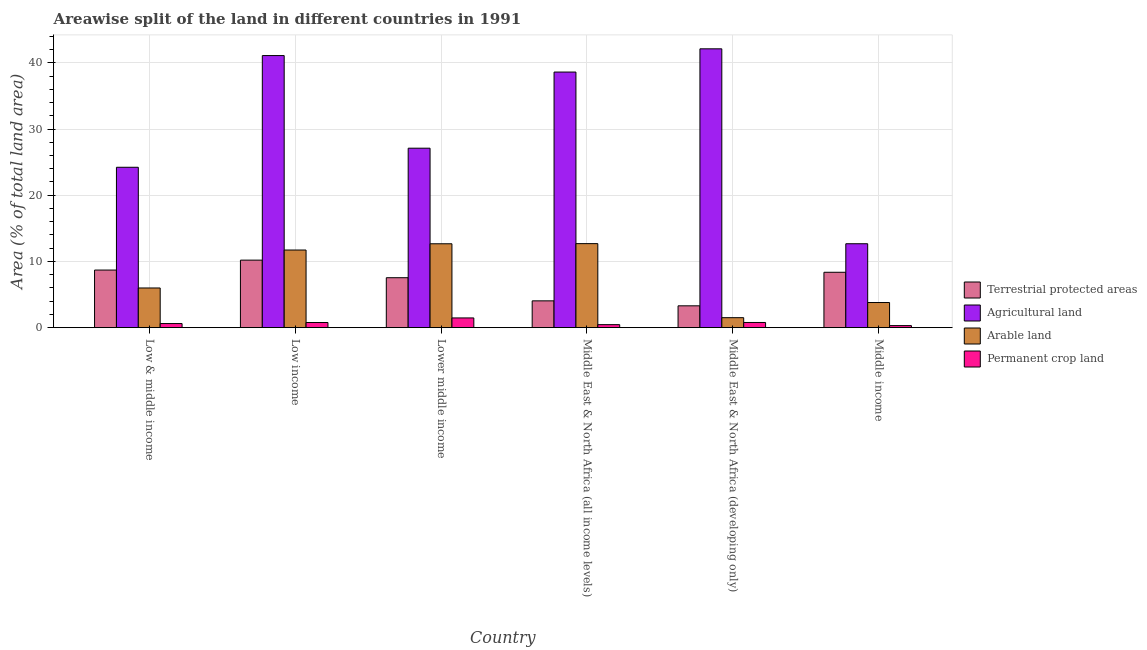How many different coloured bars are there?
Your response must be concise. 4. How many bars are there on the 3rd tick from the left?
Offer a very short reply. 4. What is the label of the 5th group of bars from the left?
Offer a very short reply. Middle East & North Africa (developing only). What is the percentage of land under terrestrial protection in Middle East & North Africa (all income levels)?
Your answer should be very brief. 4.05. Across all countries, what is the maximum percentage of area under permanent crop land?
Keep it short and to the point. 1.47. Across all countries, what is the minimum percentage of area under agricultural land?
Ensure brevity in your answer.  12.68. In which country was the percentage of area under permanent crop land maximum?
Give a very brief answer. Lower middle income. What is the total percentage of land under terrestrial protection in the graph?
Keep it short and to the point. 42.16. What is the difference between the percentage of area under arable land in Low & middle income and that in Lower middle income?
Ensure brevity in your answer.  -6.68. What is the difference between the percentage of land under terrestrial protection in Lower middle income and the percentage of area under permanent crop land in Middle East & North Africa (developing only)?
Give a very brief answer. 6.76. What is the average percentage of area under agricultural land per country?
Give a very brief answer. 30.97. What is the difference between the percentage of area under agricultural land and percentage of land under terrestrial protection in Low & middle income?
Offer a very short reply. 15.52. What is the ratio of the percentage of area under agricultural land in Low income to that in Middle income?
Provide a succinct answer. 3.24. Is the percentage of area under arable land in Low & middle income less than that in Middle income?
Keep it short and to the point. No. Is the difference between the percentage of area under agricultural land in Low & middle income and Middle East & North Africa (all income levels) greater than the difference between the percentage of area under permanent crop land in Low & middle income and Middle East & North Africa (all income levels)?
Offer a terse response. No. What is the difference between the highest and the second highest percentage of area under arable land?
Make the answer very short. 0.02. What is the difference between the highest and the lowest percentage of area under permanent crop land?
Your answer should be compact. 1.16. Is it the case that in every country, the sum of the percentage of area under agricultural land and percentage of land under terrestrial protection is greater than the sum of percentage of area under arable land and percentage of area under permanent crop land?
Make the answer very short. Yes. What does the 3rd bar from the left in Low income represents?
Your answer should be compact. Arable land. What does the 2nd bar from the right in Low & middle income represents?
Provide a succinct answer. Arable land. How many bars are there?
Offer a very short reply. 24. Are all the bars in the graph horizontal?
Keep it short and to the point. No. How many countries are there in the graph?
Your answer should be very brief. 6. What is the difference between two consecutive major ticks on the Y-axis?
Keep it short and to the point. 10. Are the values on the major ticks of Y-axis written in scientific E-notation?
Offer a very short reply. No. Does the graph contain any zero values?
Your response must be concise. No. How many legend labels are there?
Ensure brevity in your answer.  4. How are the legend labels stacked?
Your response must be concise. Vertical. What is the title of the graph?
Your response must be concise. Areawise split of the land in different countries in 1991. Does "Trade" appear as one of the legend labels in the graph?
Provide a short and direct response. No. What is the label or title of the Y-axis?
Offer a very short reply. Area (% of total land area). What is the Area (% of total land area) of Terrestrial protected areas in Low & middle income?
Offer a terse response. 8.7. What is the Area (% of total land area) of Agricultural land in Low & middle income?
Your answer should be compact. 24.22. What is the Area (% of total land area) of Arable land in Low & middle income?
Your answer should be compact. 5.99. What is the Area (% of total land area) of Permanent crop land in Low & middle income?
Offer a very short reply. 0.62. What is the Area (% of total land area) of Terrestrial protected areas in Low income?
Your response must be concise. 10.2. What is the Area (% of total land area) of Agricultural land in Low income?
Ensure brevity in your answer.  41.09. What is the Area (% of total land area) of Arable land in Low income?
Offer a terse response. 11.73. What is the Area (% of total land area) in Permanent crop land in Low income?
Ensure brevity in your answer.  0.78. What is the Area (% of total land area) in Terrestrial protected areas in Lower middle income?
Provide a succinct answer. 7.54. What is the Area (% of total land area) of Agricultural land in Lower middle income?
Make the answer very short. 27.1. What is the Area (% of total land area) in Arable land in Lower middle income?
Your answer should be very brief. 12.67. What is the Area (% of total land area) in Permanent crop land in Lower middle income?
Offer a very short reply. 1.47. What is the Area (% of total land area) of Terrestrial protected areas in Middle East & North Africa (all income levels)?
Keep it short and to the point. 4.05. What is the Area (% of total land area) of Agricultural land in Middle East & North Africa (all income levels)?
Ensure brevity in your answer.  38.6. What is the Area (% of total land area) of Arable land in Middle East & North Africa (all income levels)?
Ensure brevity in your answer.  12.69. What is the Area (% of total land area) of Permanent crop land in Middle East & North Africa (all income levels)?
Offer a terse response. 0.46. What is the Area (% of total land area) in Terrestrial protected areas in Middle East & North Africa (developing only)?
Give a very brief answer. 3.3. What is the Area (% of total land area) of Agricultural land in Middle East & North Africa (developing only)?
Offer a terse response. 42.11. What is the Area (% of total land area) in Arable land in Middle East & North Africa (developing only)?
Your response must be concise. 1.51. What is the Area (% of total land area) in Permanent crop land in Middle East & North Africa (developing only)?
Ensure brevity in your answer.  0.78. What is the Area (% of total land area) in Terrestrial protected areas in Middle income?
Make the answer very short. 8.36. What is the Area (% of total land area) in Agricultural land in Middle income?
Your answer should be compact. 12.68. What is the Area (% of total land area) in Arable land in Middle income?
Offer a very short reply. 3.8. What is the Area (% of total land area) of Permanent crop land in Middle income?
Ensure brevity in your answer.  0.31. Across all countries, what is the maximum Area (% of total land area) of Terrestrial protected areas?
Ensure brevity in your answer.  10.2. Across all countries, what is the maximum Area (% of total land area) in Agricultural land?
Your response must be concise. 42.11. Across all countries, what is the maximum Area (% of total land area) of Arable land?
Keep it short and to the point. 12.69. Across all countries, what is the maximum Area (% of total land area) of Permanent crop land?
Provide a short and direct response. 1.47. Across all countries, what is the minimum Area (% of total land area) in Terrestrial protected areas?
Give a very brief answer. 3.3. Across all countries, what is the minimum Area (% of total land area) of Agricultural land?
Make the answer very short. 12.68. Across all countries, what is the minimum Area (% of total land area) in Arable land?
Your answer should be compact. 1.51. Across all countries, what is the minimum Area (% of total land area) in Permanent crop land?
Provide a short and direct response. 0.31. What is the total Area (% of total land area) in Terrestrial protected areas in the graph?
Make the answer very short. 42.16. What is the total Area (% of total land area) of Agricultural land in the graph?
Ensure brevity in your answer.  185.81. What is the total Area (% of total land area) of Arable land in the graph?
Provide a succinct answer. 48.39. What is the total Area (% of total land area) of Permanent crop land in the graph?
Provide a short and direct response. 4.42. What is the difference between the Area (% of total land area) in Terrestrial protected areas in Low & middle income and that in Low income?
Offer a very short reply. -1.5. What is the difference between the Area (% of total land area) in Agricultural land in Low & middle income and that in Low income?
Offer a terse response. -16.87. What is the difference between the Area (% of total land area) of Arable land in Low & middle income and that in Low income?
Ensure brevity in your answer.  -5.73. What is the difference between the Area (% of total land area) of Permanent crop land in Low & middle income and that in Low income?
Provide a short and direct response. -0.16. What is the difference between the Area (% of total land area) in Terrestrial protected areas in Low & middle income and that in Lower middle income?
Make the answer very short. 1.16. What is the difference between the Area (% of total land area) in Agricultural land in Low & middle income and that in Lower middle income?
Offer a terse response. -2.88. What is the difference between the Area (% of total land area) of Arable land in Low & middle income and that in Lower middle income?
Ensure brevity in your answer.  -6.68. What is the difference between the Area (% of total land area) in Permanent crop land in Low & middle income and that in Lower middle income?
Offer a very short reply. -0.85. What is the difference between the Area (% of total land area) in Terrestrial protected areas in Low & middle income and that in Middle East & North Africa (all income levels)?
Give a very brief answer. 4.65. What is the difference between the Area (% of total land area) of Agricultural land in Low & middle income and that in Middle East & North Africa (all income levels)?
Ensure brevity in your answer.  -14.38. What is the difference between the Area (% of total land area) in Arable land in Low & middle income and that in Middle East & North Africa (all income levels)?
Ensure brevity in your answer.  -6.7. What is the difference between the Area (% of total land area) of Permanent crop land in Low & middle income and that in Middle East & North Africa (all income levels)?
Keep it short and to the point. 0.17. What is the difference between the Area (% of total land area) in Terrestrial protected areas in Low & middle income and that in Middle East & North Africa (developing only)?
Keep it short and to the point. 5.4. What is the difference between the Area (% of total land area) of Agricultural land in Low & middle income and that in Middle East & North Africa (developing only)?
Provide a short and direct response. -17.89. What is the difference between the Area (% of total land area) in Arable land in Low & middle income and that in Middle East & North Africa (developing only)?
Give a very brief answer. 4.49. What is the difference between the Area (% of total land area) of Permanent crop land in Low & middle income and that in Middle East & North Africa (developing only)?
Provide a short and direct response. -0.16. What is the difference between the Area (% of total land area) of Terrestrial protected areas in Low & middle income and that in Middle income?
Provide a short and direct response. 0.34. What is the difference between the Area (% of total land area) in Agricultural land in Low & middle income and that in Middle income?
Your answer should be very brief. 11.55. What is the difference between the Area (% of total land area) of Arable land in Low & middle income and that in Middle income?
Provide a short and direct response. 2.2. What is the difference between the Area (% of total land area) in Permanent crop land in Low & middle income and that in Middle income?
Provide a short and direct response. 0.31. What is the difference between the Area (% of total land area) in Terrestrial protected areas in Low income and that in Lower middle income?
Your response must be concise. 2.65. What is the difference between the Area (% of total land area) of Agricultural land in Low income and that in Lower middle income?
Ensure brevity in your answer.  13.99. What is the difference between the Area (% of total land area) of Arable land in Low income and that in Lower middle income?
Provide a succinct answer. -0.94. What is the difference between the Area (% of total land area) of Permanent crop land in Low income and that in Lower middle income?
Your answer should be compact. -0.69. What is the difference between the Area (% of total land area) of Terrestrial protected areas in Low income and that in Middle East & North Africa (all income levels)?
Ensure brevity in your answer.  6.15. What is the difference between the Area (% of total land area) in Agricultural land in Low income and that in Middle East & North Africa (all income levels)?
Your response must be concise. 2.49. What is the difference between the Area (% of total land area) in Arable land in Low income and that in Middle East & North Africa (all income levels)?
Offer a very short reply. -0.96. What is the difference between the Area (% of total land area) in Permanent crop land in Low income and that in Middle East & North Africa (all income levels)?
Offer a terse response. 0.32. What is the difference between the Area (% of total land area) in Terrestrial protected areas in Low income and that in Middle East & North Africa (developing only)?
Provide a short and direct response. 6.9. What is the difference between the Area (% of total land area) in Agricultural land in Low income and that in Middle East & North Africa (developing only)?
Your response must be concise. -1.02. What is the difference between the Area (% of total land area) of Arable land in Low income and that in Middle East & North Africa (developing only)?
Offer a very short reply. 10.22. What is the difference between the Area (% of total land area) in Permanent crop land in Low income and that in Middle East & North Africa (developing only)?
Your response must be concise. -0.01. What is the difference between the Area (% of total land area) of Terrestrial protected areas in Low income and that in Middle income?
Ensure brevity in your answer.  1.83. What is the difference between the Area (% of total land area) of Agricultural land in Low income and that in Middle income?
Your answer should be very brief. 28.42. What is the difference between the Area (% of total land area) of Arable land in Low income and that in Middle income?
Your answer should be very brief. 7.93. What is the difference between the Area (% of total land area) in Permanent crop land in Low income and that in Middle income?
Provide a short and direct response. 0.47. What is the difference between the Area (% of total land area) of Terrestrial protected areas in Lower middle income and that in Middle East & North Africa (all income levels)?
Your answer should be very brief. 3.49. What is the difference between the Area (% of total land area) of Agricultural land in Lower middle income and that in Middle East & North Africa (all income levels)?
Provide a short and direct response. -11.5. What is the difference between the Area (% of total land area) in Arable land in Lower middle income and that in Middle East & North Africa (all income levels)?
Your response must be concise. -0.02. What is the difference between the Area (% of total land area) of Permanent crop land in Lower middle income and that in Middle East & North Africa (all income levels)?
Offer a very short reply. 1.01. What is the difference between the Area (% of total land area) of Terrestrial protected areas in Lower middle income and that in Middle East & North Africa (developing only)?
Provide a short and direct response. 4.25. What is the difference between the Area (% of total land area) of Agricultural land in Lower middle income and that in Middle East & North Africa (developing only)?
Keep it short and to the point. -15.01. What is the difference between the Area (% of total land area) of Arable land in Lower middle income and that in Middle East & North Africa (developing only)?
Your answer should be very brief. 11.16. What is the difference between the Area (% of total land area) of Permanent crop land in Lower middle income and that in Middle East & North Africa (developing only)?
Ensure brevity in your answer.  0.69. What is the difference between the Area (% of total land area) in Terrestrial protected areas in Lower middle income and that in Middle income?
Provide a short and direct response. -0.82. What is the difference between the Area (% of total land area) of Agricultural land in Lower middle income and that in Middle income?
Make the answer very short. 14.43. What is the difference between the Area (% of total land area) in Arable land in Lower middle income and that in Middle income?
Make the answer very short. 8.87. What is the difference between the Area (% of total land area) of Permanent crop land in Lower middle income and that in Middle income?
Give a very brief answer. 1.16. What is the difference between the Area (% of total land area) of Terrestrial protected areas in Middle East & North Africa (all income levels) and that in Middle East & North Africa (developing only)?
Provide a short and direct response. 0.75. What is the difference between the Area (% of total land area) in Agricultural land in Middle East & North Africa (all income levels) and that in Middle East & North Africa (developing only)?
Your response must be concise. -3.51. What is the difference between the Area (% of total land area) in Arable land in Middle East & North Africa (all income levels) and that in Middle East & North Africa (developing only)?
Offer a very short reply. 11.18. What is the difference between the Area (% of total land area) in Permanent crop land in Middle East & North Africa (all income levels) and that in Middle East & North Africa (developing only)?
Your answer should be very brief. -0.33. What is the difference between the Area (% of total land area) in Terrestrial protected areas in Middle East & North Africa (all income levels) and that in Middle income?
Make the answer very short. -4.31. What is the difference between the Area (% of total land area) in Agricultural land in Middle East & North Africa (all income levels) and that in Middle income?
Your response must be concise. 25.93. What is the difference between the Area (% of total land area) in Arable land in Middle East & North Africa (all income levels) and that in Middle income?
Offer a very short reply. 8.9. What is the difference between the Area (% of total land area) in Permanent crop land in Middle East & North Africa (all income levels) and that in Middle income?
Your answer should be very brief. 0.14. What is the difference between the Area (% of total land area) in Terrestrial protected areas in Middle East & North Africa (developing only) and that in Middle income?
Offer a very short reply. -5.07. What is the difference between the Area (% of total land area) in Agricultural land in Middle East & North Africa (developing only) and that in Middle income?
Keep it short and to the point. 29.44. What is the difference between the Area (% of total land area) in Arable land in Middle East & North Africa (developing only) and that in Middle income?
Provide a short and direct response. -2.29. What is the difference between the Area (% of total land area) in Permanent crop land in Middle East & North Africa (developing only) and that in Middle income?
Offer a terse response. 0.47. What is the difference between the Area (% of total land area) in Terrestrial protected areas in Low & middle income and the Area (% of total land area) in Agricultural land in Low income?
Your answer should be compact. -32.39. What is the difference between the Area (% of total land area) in Terrestrial protected areas in Low & middle income and the Area (% of total land area) in Arable land in Low income?
Offer a very short reply. -3.03. What is the difference between the Area (% of total land area) of Terrestrial protected areas in Low & middle income and the Area (% of total land area) of Permanent crop land in Low income?
Your answer should be very brief. 7.92. What is the difference between the Area (% of total land area) of Agricultural land in Low & middle income and the Area (% of total land area) of Arable land in Low income?
Make the answer very short. 12.5. What is the difference between the Area (% of total land area) in Agricultural land in Low & middle income and the Area (% of total land area) in Permanent crop land in Low income?
Your response must be concise. 23.45. What is the difference between the Area (% of total land area) of Arable land in Low & middle income and the Area (% of total land area) of Permanent crop land in Low income?
Your answer should be compact. 5.22. What is the difference between the Area (% of total land area) of Terrestrial protected areas in Low & middle income and the Area (% of total land area) of Agricultural land in Lower middle income?
Provide a succinct answer. -18.4. What is the difference between the Area (% of total land area) of Terrestrial protected areas in Low & middle income and the Area (% of total land area) of Arable land in Lower middle income?
Offer a very short reply. -3.97. What is the difference between the Area (% of total land area) in Terrestrial protected areas in Low & middle income and the Area (% of total land area) in Permanent crop land in Lower middle income?
Give a very brief answer. 7.23. What is the difference between the Area (% of total land area) in Agricultural land in Low & middle income and the Area (% of total land area) in Arable land in Lower middle income?
Your answer should be compact. 11.55. What is the difference between the Area (% of total land area) of Agricultural land in Low & middle income and the Area (% of total land area) of Permanent crop land in Lower middle income?
Provide a succinct answer. 22.75. What is the difference between the Area (% of total land area) in Arable land in Low & middle income and the Area (% of total land area) in Permanent crop land in Lower middle income?
Provide a short and direct response. 4.52. What is the difference between the Area (% of total land area) in Terrestrial protected areas in Low & middle income and the Area (% of total land area) in Agricultural land in Middle East & North Africa (all income levels)?
Offer a very short reply. -29.9. What is the difference between the Area (% of total land area) in Terrestrial protected areas in Low & middle income and the Area (% of total land area) in Arable land in Middle East & North Africa (all income levels)?
Offer a terse response. -3.99. What is the difference between the Area (% of total land area) in Terrestrial protected areas in Low & middle income and the Area (% of total land area) in Permanent crop land in Middle East & North Africa (all income levels)?
Make the answer very short. 8.24. What is the difference between the Area (% of total land area) of Agricultural land in Low & middle income and the Area (% of total land area) of Arable land in Middle East & North Africa (all income levels)?
Your answer should be compact. 11.53. What is the difference between the Area (% of total land area) in Agricultural land in Low & middle income and the Area (% of total land area) in Permanent crop land in Middle East & North Africa (all income levels)?
Your answer should be very brief. 23.77. What is the difference between the Area (% of total land area) in Arable land in Low & middle income and the Area (% of total land area) in Permanent crop land in Middle East & North Africa (all income levels)?
Your answer should be very brief. 5.54. What is the difference between the Area (% of total land area) in Terrestrial protected areas in Low & middle income and the Area (% of total land area) in Agricultural land in Middle East & North Africa (developing only)?
Give a very brief answer. -33.41. What is the difference between the Area (% of total land area) in Terrestrial protected areas in Low & middle income and the Area (% of total land area) in Arable land in Middle East & North Africa (developing only)?
Make the answer very short. 7.19. What is the difference between the Area (% of total land area) in Terrestrial protected areas in Low & middle income and the Area (% of total land area) in Permanent crop land in Middle East & North Africa (developing only)?
Give a very brief answer. 7.92. What is the difference between the Area (% of total land area) in Agricultural land in Low & middle income and the Area (% of total land area) in Arable land in Middle East & North Africa (developing only)?
Offer a terse response. 22.72. What is the difference between the Area (% of total land area) in Agricultural land in Low & middle income and the Area (% of total land area) in Permanent crop land in Middle East & North Africa (developing only)?
Your answer should be very brief. 23.44. What is the difference between the Area (% of total land area) of Arable land in Low & middle income and the Area (% of total land area) of Permanent crop land in Middle East & North Africa (developing only)?
Offer a terse response. 5.21. What is the difference between the Area (% of total land area) of Terrestrial protected areas in Low & middle income and the Area (% of total land area) of Agricultural land in Middle income?
Offer a terse response. -3.98. What is the difference between the Area (% of total land area) in Terrestrial protected areas in Low & middle income and the Area (% of total land area) in Arable land in Middle income?
Offer a terse response. 4.9. What is the difference between the Area (% of total land area) in Terrestrial protected areas in Low & middle income and the Area (% of total land area) in Permanent crop land in Middle income?
Your response must be concise. 8.39. What is the difference between the Area (% of total land area) in Agricultural land in Low & middle income and the Area (% of total land area) in Arable land in Middle income?
Offer a very short reply. 20.43. What is the difference between the Area (% of total land area) in Agricultural land in Low & middle income and the Area (% of total land area) in Permanent crop land in Middle income?
Provide a short and direct response. 23.91. What is the difference between the Area (% of total land area) in Arable land in Low & middle income and the Area (% of total land area) in Permanent crop land in Middle income?
Offer a terse response. 5.68. What is the difference between the Area (% of total land area) of Terrestrial protected areas in Low income and the Area (% of total land area) of Agricultural land in Lower middle income?
Give a very brief answer. -16.9. What is the difference between the Area (% of total land area) of Terrestrial protected areas in Low income and the Area (% of total land area) of Arable land in Lower middle income?
Keep it short and to the point. -2.47. What is the difference between the Area (% of total land area) in Terrestrial protected areas in Low income and the Area (% of total land area) in Permanent crop land in Lower middle income?
Keep it short and to the point. 8.73. What is the difference between the Area (% of total land area) of Agricultural land in Low income and the Area (% of total land area) of Arable land in Lower middle income?
Provide a short and direct response. 28.42. What is the difference between the Area (% of total land area) in Agricultural land in Low income and the Area (% of total land area) in Permanent crop land in Lower middle income?
Ensure brevity in your answer.  39.62. What is the difference between the Area (% of total land area) of Arable land in Low income and the Area (% of total land area) of Permanent crop land in Lower middle income?
Your response must be concise. 10.26. What is the difference between the Area (% of total land area) in Terrestrial protected areas in Low income and the Area (% of total land area) in Agricultural land in Middle East & North Africa (all income levels)?
Ensure brevity in your answer.  -28.4. What is the difference between the Area (% of total land area) of Terrestrial protected areas in Low income and the Area (% of total land area) of Arable land in Middle East & North Africa (all income levels)?
Your answer should be compact. -2.49. What is the difference between the Area (% of total land area) of Terrestrial protected areas in Low income and the Area (% of total land area) of Permanent crop land in Middle East & North Africa (all income levels)?
Make the answer very short. 9.74. What is the difference between the Area (% of total land area) of Agricultural land in Low income and the Area (% of total land area) of Arable land in Middle East & North Africa (all income levels)?
Your response must be concise. 28.4. What is the difference between the Area (% of total land area) in Agricultural land in Low income and the Area (% of total land area) in Permanent crop land in Middle East & North Africa (all income levels)?
Ensure brevity in your answer.  40.64. What is the difference between the Area (% of total land area) in Arable land in Low income and the Area (% of total land area) in Permanent crop land in Middle East & North Africa (all income levels)?
Keep it short and to the point. 11.27. What is the difference between the Area (% of total land area) in Terrestrial protected areas in Low income and the Area (% of total land area) in Agricultural land in Middle East & North Africa (developing only)?
Give a very brief answer. -31.91. What is the difference between the Area (% of total land area) in Terrestrial protected areas in Low income and the Area (% of total land area) in Arable land in Middle East & North Africa (developing only)?
Provide a short and direct response. 8.69. What is the difference between the Area (% of total land area) of Terrestrial protected areas in Low income and the Area (% of total land area) of Permanent crop land in Middle East & North Africa (developing only)?
Make the answer very short. 9.41. What is the difference between the Area (% of total land area) of Agricultural land in Low income and the Area (% of total land area) of Arable land in Middle East & North Africa (developing only)?
Offer a terse response. 39.59. What is the difference between the Area (% of total land area) of Agricultural land in Low income and the Area (% of total land area) of Permanent crop land in Middle East & North Africa (developing only)?
Ensure brevity in your answer.  40.31. What is the difference between the Area (% of total land area) of Arable land in Low income and the Area (% of total land area) of Permanent crop land in Middle East & North Africa (developing only)?
Your response must be concise. 10.94. What is the difference between the Area (% of total land area) in Terrestrial protected areas in Low income and the Area (% of total land area) in Agricultural land in Middle income?
Provide a succinct answer. -2.48. What is the difference between the Area (% of total land area) in Terrestrial protected areas in Low income and the Area (% of total land area) in Arable land in Middle income?
Your response must be concise. 6.4. What is the difference between the Area (% of total land area) in Terrestrial protected areas in Low income and the Area (% of total land area) in Permanent crop land in Middle income?
Give a very brief answer. 9.89. What is the difference between the Area (% of total land area) of Agricultural land in Low income and the Area (% of total land area) of Arable land in Middle income?
Make the answer very short. 37.3. What is the difference between the Area (% of total land area) of Agricultural land in Low income and the Area (% of total land area) of Permanent crop land in Middle income?
Ensure brevity in your answer.  40.78. What is the difference between the Area (% of total land area) in Arable land in Low income and the Area (% of total land area) in Permanent crop land in Middle income?
Make the answer very short. 11.42. What is the difference between the Area (% of total land area) of Terrestrial protected areas in Lower middle income and the Area (% of total land area) of Agricultural land in Middle East & North Africa (all income levels)?
Provide a short and direct response. -31.06. What is the difference between the Area (% of total land area) in Terrestrial protected areas in Lower middle income and the Area (% of total land area) in Arable land in Middle East & North Africa (all income levels)?
Offer a terse response. -5.15. What is the difference between the Area (% of total land area) of Terrestrial protected areas in Lower middle income and the Area (% of total land area) of Permanent crop land in Middle East & North Africa (all income levels)?
Provide a short and direct response. 7.09. What is the difference between the Area (% of total land area) of Agricultural land in Lower middle income and the Area (% of total land area) of Arable land in Middle East & North Africa (all income levels)?
Keep it short and to the point. 14.41. What is the difference between the Area (% of total land area) in Agricultural land in Lower middle income and the Area (% of total land area) in Permanent crop land in Middle East & North Africa (all income levels)?
Offer a very short reply. 26.65. What is the difference between the Area (% of total land area) in Arable land in Lower middle income and the Area (% of total land area) in Permanent crop land in Middle East & North Africa (all income levels)?
Ensure brevity in your answer.  12.21. What is the difference between the Area (% of total land area) in Terrestrial protected areas in Lower middle income and the Area (% of total land area) in Agricultural land in Middle East & North Africa (developing only)?
Keep it short and to the point. -34.57. What is the difference between the Area (% of total land area) in Terrestrial protected areas in Lower middle income and the Area (% of total land area) in Arable land in Middle East & North Africa (developing only)?
Offer a terse response. 6.04. What is the difference between the Area (% of total land area) of Terrestrial protected areas in Lower middle income and the Area (% of total land area) of Permanent crop land in Middle East & North Africa (developing only)?
Ensure brevity in your answer.  6.76. What is the difference between the Area (% of total land area) of Agricultural land in Lower middle income and the Area (% of total land area) of Arable land in Middle East & North Africa (developing only)?
Keep it short and to the point. 25.6. What is the difference between the Area (% of total land area) of Agricultural land in Lower middle income and the Area (% of total land area) of Permanent crop land in Middle East & North Africa (developing only)?
Ensure brevity in your answer.  26.32. What is the difference between the Area (% of total land area) in Arable land in Lower middle income and the Area (% of total land area) in Permanent crop land in Middle East & North Africa (developing only)?
Your answer should be very brief. 11.88. What is the difference between the Area (% of total land area) in Terrestrial protected areas in Lower middle income and the Area (% of total land area) in Agricultural land in Middle income?
Your answer should be compact. -5.13. What is the difference between the Area (% of total land area) of Terrestrial protected areas in Lower middle income and the Area (% of total land area) of Arable land in Middle income?
Make the answer very short. 3.75. What is the difference between the Area (% of total land area) in Terrestrial protected areas in Lower middle income and the Area (% of total land area) in Permanent crop land in Middle income?
Keep it short and to the point. 7.23. What is the difference between the Area (% of total land area) in Agricultural land in Lower middle income and the Area (% of total land area) in Arable land in Middle income?
Make the answer very short. 23.31. What is the difference between the Area (% of total land area) in Agricultural land in Lower middle income and the Area (% of total land area) in Permanent crop land in Middle income?
Your answer should be very brief. 26.79. What is the difference between the Area (% of total land area) in Arable land in Lower middle income and the Area (% of total land area) in Permanent crop land in Middle income?
Your response must be concise. 12.36. What is the difference between the Area (% of total land area) in Terrestrial protected areas in Middle East & North Africa (all income levels) and the Area (% of total land area) in Agricultural land in Middle East & North Africa (developing only)?
Make the answer very short. -38.06. What is the difference between the Area (% of total land area) of Terrestrial protected areas in Middle East & North Africa (all income levels) and the Area (% of total land area) of Arable land in Middle East & North Africa (developing only)?
Your answer should be compact. 2.54. What is the difference between the Area (% of total land area) of Terrestrial protected areas in Middle East & North Africa (all income levels) and the Area (% of total land area) of Permanent crop land in Middle East & North Africa (developing only)?
Provide a short and direct response. 3.27. What is the difference between the Area (% of total land area) of Agricultural land in Middle East & North Africa (all income levels) and the Area (% of total land area) of Arable land in Middle East & North Africa (developing only)?
Your response must be concise. 37.1. What is the difference between the Area (% of total land area) of Agricultural land in Middle East & North Africa (all income levels) and the Area (% of total land area) of Permanent crop land in Middle East & North Africa (developing only)?
Give a very brief answer. 37.82. What is the difference between the Area (% of total land area) of Arable land in Middle East & North Africa (all income levels) and the Area (% of total land area) of Permanent crop land in Middle East & North Africa (developing only)?
Give a very brief answer. 11.91. What is the difference between the Area (% of total land area) in Terrestrial protected areas in Middle East & North Africa (all income levels) and the Area (% of total land area) in Agricultural land in Middle income?
Your answer should be very brief. -8.63. What is the difference between the Area (% of total land area) of Terrestrial protected areas in Middle East & North Africa (all income levels) and the Area (% of total land area) of Arable land in Middle income?
Give a very brief answer. 0.25. What is the difference between the Area (% of total land area) in Terrestrial protected areas in Middle East & North Africa (all income levels) and the Area (% of total land area) in Permanent crop land in Middle income?
Make the answer very short. 3.74. What is the difference between the Area (% of total land area) of Agricultural land in Middle East & North Africa (all income levels) and the Area (% of total land area) of Arable land in Middle income?
Keep it short and to the point. 34.81. What is the difference between the Area (% of total land area) in Agricultural land in Middle East & North Africa (all income levels) and the Area (% of total land area) in Permanent crop land in Middle income?
Your response must be concise. 38.29. What is the difference between the Area (% of total land area) in Arable land in Middle East & North Africa (all income levels) and the Area (% of total land area) in Permanent crop land in Middle income?
Ensure brevity in your answer.  12.38. What is the difference between the Area (% of total land area) in Terrestrial protected areas in Middle East & North Africa (developing only) and the Area (% of total land area) in Agricultural land in Middle income?
Your response must be concise. -9.38. What is the difference between the Area (% of total land area) of Terrestrial protected areas in Middle East & North Africa (developing only) and the Area (% of total land area) of Arable land in Middle income?
Your answer should be very brief. -0.5. What is the difference between the Area (% of total land area) in Terrestrial protected areas in Middle East & North Africa (developing only) and the Area (% of total land area) in Permanent crop land in Middle income?
Provide a succinct answer. 2.99. What is the difference between the Area (% of total land area) of Agricultural land in Middle East & North Africa (developing only) and the Area (% of total land area) of Arable land in Middle income?
Give a very brief answer. 38.32. What is the difference between the Area (% of total land area) in Agricultural land in Middle East & North Africa (developing only) and the Area (% of total land area) in Permanent crop land in Middle income?
Ensure brevity in your answer.  41.8. What is the difference between the Area (% of total land area) of Arable land in Middle East & North Africa (developing only) and the Area (% of total land area) of Permanent crop land in Middle income?
Ensure brevity in your answer.  1.2. What is the average Area (% of total land area) in Terrestrial protected areas per country?
Make the answer very short. 7.03. What is the average Area (% of total land area) of Agricultural land per country?
Your response must be concise. 30.97. What is the average Area (% of total land area) of Arable land per country?
Your answer should be compact. 8.06. What is the average Area (% of total land area) in Permanent crop land per country?
Provide a succinct answer. 0.74. What is the difference between the Area (% of total land area) of Terrestrial protected areas and Area (% of total land area) of Agricultural land in Low & middle income?
Offer a terse response. -15.52. What is the difference between the Area (% of total land area) of Terrestrial protected areas and Area (% of total land area) of Arable land in Low & middle income?
Keep it short and to the point. 2.71. What is the difference between the Area (% of total land area) in Terrestrial protected areas and Area (% of total land area) in Permanent crop land in Low & middle income?
Your response must be concise. 8.08. What is the difference between the Area (% of total land area) in Agricultural land and Area (% of total land area) in Arable land in Low & middle income?
Provide a succinct answer. 18.23. What is the difference between the Area (% of total land area) in Agricultural land and Area (% of total land area) in Permanent crop land in Low & middle income?
Provide a short and direct response. 23.6. What is the difference between the Area (% of total land area) in Arable land and Area (% of total land area) in Permanent crop land in Low & middle income?
Offer a very short reply. 5.37. What is the difference between the Area (% of total land area) of Terrestrial protected areas and Area (% of total land area) of Agricultural land in Low income?
Offer a terse response. -30.89. What is the difference between the Area (% of total land area) of Terrestrial protected areas and Area (% of total land area) of Arable land in Low income?
Offer a very short reply. -1.53. What is the difference between the Area (% of total land area) in Terrestrial protected areas and Area (% of total land area) in Permanent crop land in Low income?
Your answer should be very brief. 9.42. What is the difference between the Area (% of total land area) of Agricultural land and Area (% of total land area) of Arable land in Low income?
Offer a very short reply. 29.37. What is the difference between the Area (% of total land area) in Agricultural land and Area (% of total land area) in Permanent crop land in Low income?
Your response must be concise. 40.32. What is the difference between the Area (% of total land area) of Arable land and Area (% of total land area) of Permanent crop land in Low income?
Your answer should be compact. 10.95. What is the difference between the Area (% of total land area) in Terrestrial protected areas and Area (% of total land area) in Agricultural land in Lower middle income?
Offer a very short reply. -19.56. What is the difference between the Area (% of total land area) of Terrestrial protected areas and Area (% of total land area) of Arable land in Lower middle income?
Your response must be concise. -5.13. What is the difference between the Area (% of total land area) in Terrestrial protected areas and Area (% of total land area) in Permanent crop land in Lower middle income?
Offer a terse response. 6.07. What is the difference between the Area (% of total land area) in Agricultural land and Area (% of total land area) in Arable land in Lower middle income?
Keep it short and to the point. 14.43. What is the difference between the Area (% of total land area) in Agricultural land and Area (% of total land area) in Permanent crop land in Lower middle income?
Your answer should be compact. 25.63. What is the difference between the Area (% of total land area) of Arable land and Area (% of total land area) of Permanent crop land in Lower middle income?
Offer a terse response. 11.2. What is the difference between the Area (% of total land area) in Terrestrial protected areas and Area (% of total land area) in Agricultural land in Middle East & North Africa (all income levels)?
Make the answer very short. -34.55. What is the difference between the Area (% of total land area) of Terrestrial protected areas and Area (% of total land area) of Arable land in Middle East & North Africa (all income levels)?
Keep it short and to the point. -8.64. What is the difference between the Area (% of total land area) in Terrestrial protected areas and Area (% of total land area) in Permanent crop land in Middle East & North Africa (all income levels)?
Offer a terse response. 3.59. What is the difference between the Area (% of total land area) in Agricultural land and Area (% of total land area) in Arable land in Middle East & North Africa (all income levels)?
Ensure brevity in your answer.  25.91. What is the difference between the Area (% of total land area) of Agricultural land and Area (% of total land area) of Permanent crop land in Middle East & North Africa (all income levels)?
Provide a succinct answer. 38.15. What is the difference between the Area (% of total land area) of Arable land and Area (% of total land area) of Permanent crop land in Middle East & North Africa (all income levels)?
Your answer should be compact. 12.24. What is the difference between the Area (% of total land area) in Terrestrial protected areas and Area (% of total land area) in Agricultural land in Middle East & North Africa (developing only)?
Your answer should be very brief. -38.81. What is the difference between the Area (% of total land area) of Terrestrial protected areas and Area (% of total land area) of Arable land in Middle East & North Africa (developing only)?
Provide a short and direct response. 1.79. What is the difference between the Area (% of total land area) of Terrestrial protected areas and Area (% of total land area) of Permanent crop land in Middle East & North Africa (developing only)?
Your answer should be compact. 2.51. What is the difference between the Area (% of total land area) in Agricultural land and Area (% of total land area) in Arable land in Middle East & North Africa (developing only)?
Offer a terse response. 40.6. What is the difference between the Area (% of total land area) of Agricultural land and Area (% of total land area) of Permanent crop land in Middle East & North Africa (developing only)?
Your answer should be very brief. 41.33. What is the difference between the Area (% of total land area) of Arable land and Area (% of total land area) of Permanent crop land in Middle East & North Africa (developing only)?
Make the answer very short. 0.72. What is the difference between the Area (% of total land area) of Terrestrial protected areas and Area (% of total land area) of Agricultural land in Middle income?
Make the answer very short. -4.31. What is the difference between the Area (% of total land area) in Terrestrial protected areas and Area (% of total land area) in Arable land in Middle income?
Your answer should be very brief. 4.57. What is the difference between the Area (% of total land area) of Terrestrial protected areas and Area (% of total land area) of Permanent crop land in Middle income?
Your answer should be compact. 8.05. What is the difference between the Area (% of total land area) of Agricultural land and Area (% of total land area) of Arable land in Middle income?
Your response must be concise. 8.88. What is the difference between the Area (% of total land area) in Agricultural land and Area (% of total land area) in Permanent crop land in Middle income?
Make the answer very short. 12.36. What is the difference between the Area (% of total land area) in Arable land and Area (% of total land area) in Permanent crop land in Middle income?
Your answer should be compact. 3.48. What is the ratio of the Area (% of total land area) of Terrestrial protected areas in Low & middle income to that in Low income?
Your answer should be compact. 0.85. What is the ratio of the Area (% of total land area) in Agricultural land in Low & middle income to that in Low income?
Ensure brevity in your answer.  0.59. What is the ratio of the Area (% of total land area) in Arable land in Low & middle income to that in Low income?
Keep it short and to the point. 0.51. What is the ratio of the Area (% of total land area) in Permanent crop land in Low & middle income to that in Low income?
Keep it short and to the point. 0.8. What is the ratio of the Area (% of total land area) in Terrestrial protected areas in Low & middle income to that in Lower middle income?
Your answer should be compact. 1.15. What is the ratio of the Area (% of total land area) of Agricultural land in Low & middle income to that in Lower middle income?
Your answer should be very brief. 0.89. What is the ratio of the Area (% of total land area) in Arable land in Low & middle income to that in Lower middle income?
Your response must be concise. 0.47. What is the ratio of the Area (% of total land area) of Permanent crop land in Low & middle income to that in Lower middle income?
Your answer should be very brief. 0.42. What is the ratio of the Area (% of total land area) of Terrestrial protected areas in Low & middle income to that in Middle East & North Africa (all income levels)?
Offer a very short reply. 2.15. What is the ratio of the Area (% of total land area) of Agricultural land in Low & middle income to that in Middle East & North Africa (all income levels)?
Your answer should be compact. 0.63. What is the ratio of the Area (% of total land area) of Arable land in Low & middle income to that in Middle East & North Africa (all income levels)?
Offer a very short reply. 0.47. What is the ratio of the Area (% of total land area) in Permanent crop land in Low & middle income to that in Middle East & North Africa (all income levels)?
Your answer should be compact. 1.36. What is the ratio of the Area (% of total land area) in Terrestrial protected areas in Low & middle income to that in Middle East & North Africa (developing only)?
Ensure brevity in your answer.  2.64. What is the ratio of the Area (% of total land area) of Agricultural land in Low & middle income to that in Middle East & North Africa (developing only)?
Make the answer very short. 0.58. What is the ratio of the Area (% of total land area) in Arable land in Low & middle income to that in Middle East & North Africa (developing only)?
Give a very brief answer. 3.98. What is the ratio of the Area (% of total land area) of Permanent crop land in Low & middle income to that in Middle East & North Africa (developing only)?
Your answer should be very brief. 0.79. What is the ratio of the Area (% of total land area) in Terrestrial protected areas in Low & middle income to that in Middle income?
Ensure brevity in your answer.  1.04. What is the ratio of the Area (% of total land area) of Agricultural land in Low & middle income to that in Middle income?
Provide a short and direct response. 1.91. What is the ratio of the Area (% of total land area) in Arable land in Low & middle income to that in Middle income?
Keep it short and to the point. 1.58. What is the ratio of the Area (% of total land area) in Permanent crop land in Low & middle income to that in Middle income?
Give a very brief answer. 2. What is the ratio of the Area (% of total land area) in Terrestrial protected areas in Low income to that in Lower middle income?
Your answer should be very brief. 1.35. What is the ratio of the Area (% of total land area) in Agricultural land in Low income to that in Lower middle income?
Offer a very short reply. 1.52. What is the ratio of the Area (% of total land area) in Arable land in Low income to that in Lower middle income?
Keep it short and to the point. 0.93. What is the ratio of the Area (% of total land area) in Permanent crop land in Low income to that in Lower middle income?
Your answer should be compact. 0.53. What is the ratio of the Area (% of total land area) of Terrestrial protected areas in Low income to that in Middle East & North Africa (all income levels)?
Offer a very short reply. 2.52. What is the ratio of the Area (% of total land area) in Agricultural land in Low income to that in Middle East & North Africa (all income levels)?
Offer a very short reply. 1.06. What is the ratio of the Area (% of total land area) of Arable land in Low income to that in Middle East & North Africa (all income levels)?
Offer a terse response. 0.92. What is the ratio of the Area (% of total land area) in Permanent crop land in Low income to that in Middle East & North Africa (all income levels)?
Your answer should be compact. 1.71. What is the ratio of the Area (% of total land area) in Terrestrial protected areas in Low income to that in Middle East & North Africa (developing only)?
Make the answer very short. 3.09. What is the ratio of the Area (% of total land area) in Agricultural land in Low income to that in Middle East & North Africa (developing only)?
Provide a succinct answer. 0.98. What is the ratio of the Area (% of total land area) in Arable land in Low income to that in Middle East & North Africa (developing only)?
Provide a short and direct response. 7.78. What is the ratio of the Area (% of total land area) of Permanent crop land in Low income to that in Middle East & North Africa (developing only)?
Your answer should be very brief. 0.99. What is the ratio of the Area (% of total land area) of Terrestrial protected areas in Low income to that in Middle income?
Your answer should be very brief. 1.22. What is the ratio of the Area (% of total land area) of Agricultural land in Low income to that in Middle income?
Your answer should be compact. 3.24. What is the ratio of the Area (% of total land area) in Arable land in Low income to that in Middle income?
Offer a terse response. 3.09. What is the ratio of the Area (% of total land area) in Permanent crop land in Low income to that in Middle income?
Keep it short and to the point. 2.5. What is the ratio of the Area (% of total land area) in Terrestrial protected areas in Lower middle income to that in Middle East & North Africa (all income levels)?
Your answer should be very brief. 1.86. What is the ratio of the Area (% of total land area) in Agricultural land in Lower middle income to that in Middle East & North Africa (all income levels)?
Keep it short and to the point. 0.7. What is the ratio of the Area (% of total land area) in Permanent crop land in Lower middle income to that in Middle East & North Africa (all income levels)?
Give a very brief answer. 3.22. What is the ratio of the Area (% of total land area) of Terrestrial protected areas in Lower middle income to that in Middle East & North Africa (developing only)?
Provide a succinct answer. 2.29. What is the ratio of the Area (% of total land area) of Agricultural land in Lower middle income to that in Middle East & North Africa (developing only)?
Provide a short and direct response. 0.64. What is the ratio of the Area (% of total land area) of Arable land in Lower middle income to that in Middle East & North Africa (developing only)?
Make the answer very short. 8.4. What is the ratio of the Area (% of total land area) of Permanent crop land in Lower middle income to that in Middle East & North Africa (developing only)?
Provide a short and direct response. 1.87. What is the ratio of the Area (% of total land area) in Terrestrial protected areas in Lower middle income to that in Middle income?
Provide a short and direct response. 0.9. What is the ratio of the Area (% of total land area) of Agricultural land in Lower middle income to that in Middle income?
Your answer should be compact. 2.14. What is the ratio of the Area (% of total land area) of Arable land in Lower middle income to that in Middle income?
Offer a very short reply. 3.34. What is the ratio of the Area (% of total land area) of Permanent crop land in Lower middle income to that in Middle income?
Your answer should be very brief. 4.73. What is the ratio of the Area (% of total land area) of Terrestrial protected areas in Middle East & North Africa (all income levels) to that in Middle East & North Africa (developing only)?
Your response must be concise. 1.23. What is the ratio of the Area (% of total land area) of Arable land in Middle East & North Africa (all income levels) to that in Middle East & North Africa (developing only)?
Offer a very short reply. 8.42. What is the ratio of the Area (% of total land area) of Permanent crop land in Middle East & North Africa (all income levels) to that in Middle East & North Africa (developing only)?
Give a very brief answer. 0.58. What is the ratio of the Area (% of total land area) in Terrestrial protected areas in Middle East & North Africa (all income levels) to that in Middle income?
Your response must be concise. 0.48. What is the ratio of the Area (% of total land area) of Agricultural land in Middle East & North Africa (all income levels) to that in Middle income?
Your response must be concise. 3.05. What is the ratio of the Area (% of total land area) of Arable land in Middle East & North Africa (all income levels) to that in Middle income?
Ensure brevity in your answer.  3.34. What is the ratio of the Area (% of total land area) in Permanent crop land in Middle East & North Africa (all income levels) to that in Middle income?
Make the answer very short. 1.47. What is the ratio of the Area (% of total land area) in Terrestrial protected areas in Middle East & North Africa (developing only) to that in Middle income?
Provide a succinct answer. 0.39. What is the ratio of the Area (% of total land area) of Agricultural land in Middle East & North Africa (developing only) to that in Middle income?
Keep it short and to the point. 3.32. What is the ratio of the Area (% of total land area) of Arable land in Middle East & North Africa (developing only) to that in Middle income?
Provide a succinct answer. 0.4. What is the ratio of the Area (% of total land area) of Permanent crop land in Middle East & North Africa (developing only) to that in Middle income?
Give a very brief answer. 2.52. What is the difference between the highest and the second highest Area (% of total land area) in Terrestrial protected areas?
Your response must be concise. 1.5. What is the difference between the highest and the second highest Area (% of total land area) of Agricultural land?
Offer a terse response. 1.02. What is the difference between the highest and the second highest Area (% of total land area) in Arable land?
Your answer should be compact. 0.02. What is the difference between the highest and the second highest Area (% of total land area) in Permanent crop land?
Your response must be concise. 0.69. What is the difference between the highest and the lowest Area (% of total land area) in Terrestrial protected areas?
Offer a very short reply. 6.9. What is the difference between the highest and the lowest Area (% of total land area) in Agricultural land?
Your answer should be very brief. 29.44. What is the difference between the highest and the lowest Area (% of total land area) in Arable land?
Provide a short and direct response. 11.18. What is the difference between the highest and the lowest Area (% of total land area) of Permanent crop land?
Offer a very short reply. 1.16. 